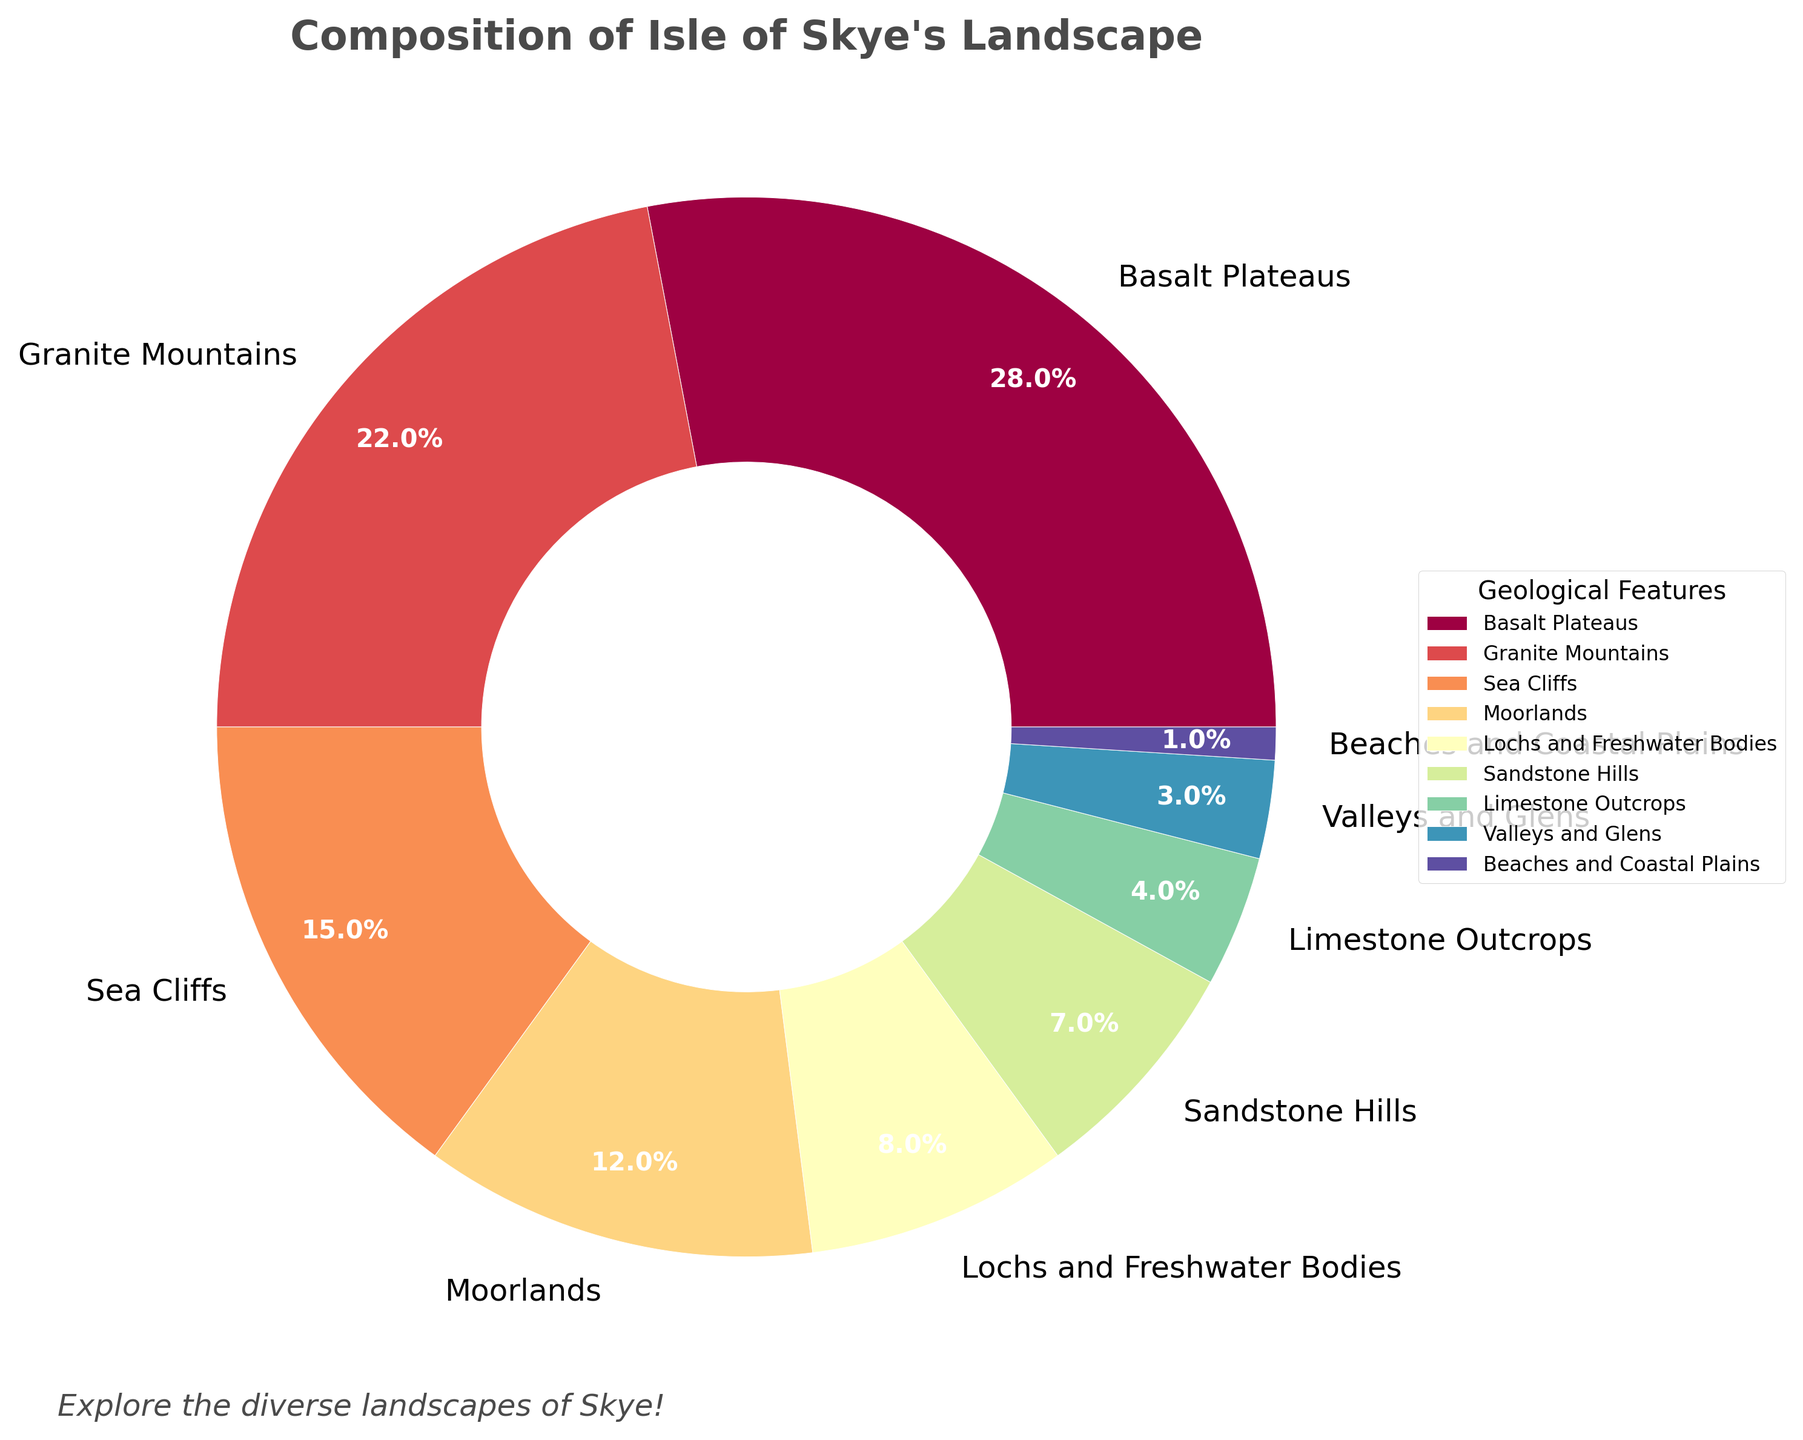Which geological feature has the highest percentage? According to the pie chart, the Basalt Plateaus have the highest percentage at 28%.
Answer: Basalt Plateaus By how much percentage do Granite Mountains exceed Sandstone Hills? The Granite Mountains have a percentage of 22%, while Sandstone Hills have 7%. The difference is 22% - 7% = 15%.
Answer: 15% What is the combined percentage of all water bodies (Lochs and Freshwater Bodies) and Beaches and Coastal Plains? Lochs and Freshwater Bodies have a percentage of 8%, and Beaches and Coastal Plains have 1%. The combined percentage is 8% + 1% = 9%.
Answer: 9% Which features have a lower percentage than Moorlands? According to the pie chart, Moorlands have 12%. The features with a lower percentage are Lochs and Freshwater Bodies (8%), Sandstone Hills (7%), Limestone Outcrops (4%), Valleys and Glens (3%), and Beaches and Coastal Plains (1%).
Answer: Lochs and Freshwater Bodies, Sandstone Hills, Limestone Outcrops, Valleys and Glens, Beaches and Coastal Plains What is the difference in percentage between the highest and lowest feature? The highest percentage feature is Basalt Plateaus at 28%, and the lowest is Beaches and Coastal Plains at 1%. The difference is 28% - 1% = 27%.
Answer: 27% Are the Limestone Outcrops more or less than Granite Mountains and by how much percentage? Limestone Outcrops are 4%, Granite Mountains are 22%. The difference is 22% - 4% = 18%. Therefore, Granite Mountains are more by 18%.
Answer: More, by 18% Which geological features cumulatively contribute exactly 50%? Combining Basalt Plateaus (28%), Granite Mountains (22%) will give exactly 50% (28% + 22%).
Answer: Basalt Plateaus, Granite Mountains 